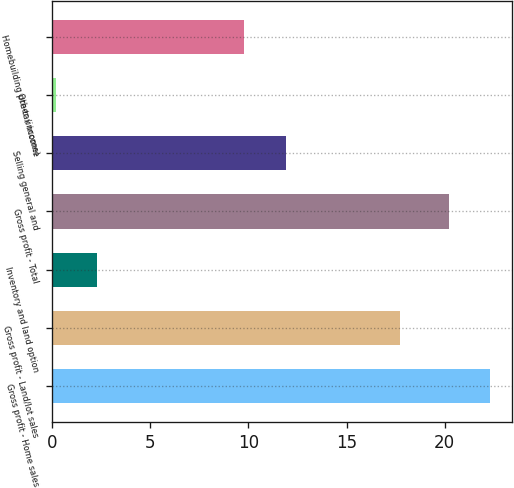Convert chart to OTSL. <chart><loc_0><loc_0><loc_500><loc_500><bar_chart><fcel>Gross profit - Home sales<fcel>Gross profit - Land/lot sales<fcel>Inventory and land option<fcel>Gross profit - Total<fcel>Selling general and<fcel>Other (income)<fcel>Homebuilding pre-tax income<nl><fcel>22.31<fcel>17.7<fcel>2.31<fcel>20.2<fcel>11.91<fcel>0.2<fcel>9.8<nl></chart> 